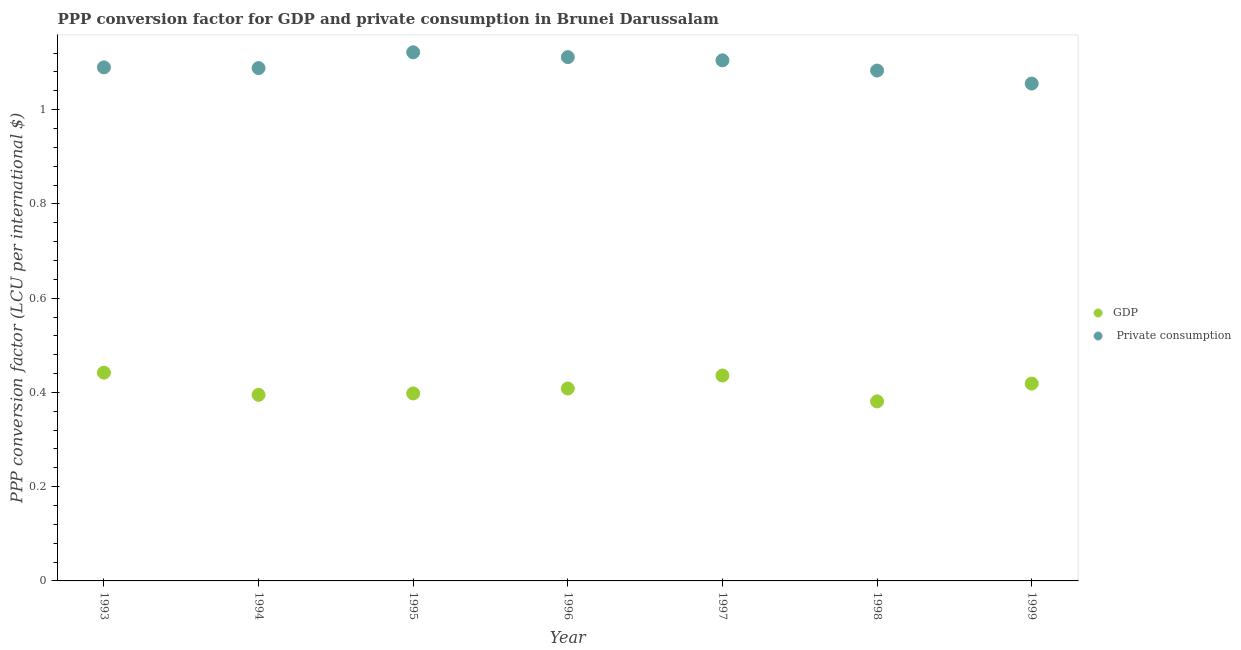How many different coloured dotlines are there?
Provide a short and direct response. 2. What is the ppp conversion factor for gdp in 1996?
Your answer should be compact. 0.41. Across all years, what is the maximum ppp conversion factor for private consumption?
Your answer should be compact. 1.12. Across all years, what is the minimum ppp conversion factor for private consumption?
Ensure brevity in your answer.  1.06. What is the total ppp conversion factor for gdp in the graph?
Provide a succinct answer. 2.88. What is the difference between the ppp conversion factor for gdp in 1993 and that in 1997?
Give a very brief answer. 0.01. What is the difference between the ppp conversion factor for gdp in 1994 and the ppp conversion factor for private consumption in 1993?
Your answer should be compact. -0.69. What is the average ppp conversion factor for gdp per year?
Your response must be concise. 0.41. In the year 1995, what is the difference between the ppp conversion factor for gdp and ppp conversion factor for private consumption?
Keep it short and to the point. -0.72. What is the ratio of the ppp conversion factor for gdp in 1995 to that in 1998?
Give a very brief answer. 1.04. Is the difference between the ppp conversion factor for private consumption in 1994 and 1999 greater than the difference between the ppp conversion factor for gdp in 1994 and 1999?
Ensure brevity in your answer.  Yes. What is the difference between the highest and the second highest ppp conversion factor for private consumption?
Keep it short and to the point. 0.01. What is the difference between the highest and the lowest ppp conversion factor for private consumption?
Give a very brief answer. 0.07. In how many years, is the ppp conversion factor for gdp greater than the average ppp conversion factor for gdp taken over all years?
Make the answer very short. 3. Is the ppp conversion factor for gdp strictly greater than the ppp conversion factor for private consumption over the years?
Offer a terse response. No. Is the ppp conversion factor for private consumption strictly less than the ppp conversion factor for gdp over the years?
Provide a short and direct response. No. How many dotlines are there?
Your response must be concise. 2. How many years are there in the graph?
Ensure brevity in your answer.  7. What is the difference between two consecutive major ticks on the Y-axis?
Provide a short and direct response. 0.2. Are the values on the major ticks of Y-axis written in scientific E-notation?
Make the answer very short. No. Does the graph contain any zero values?
Provide a succinct answer. No. How are the legend labels stacked?
Give a very brief answer. Vertical. What is the title of the graph?
Provide a succinct answer. PPP conversion factor for GDP and private consumption in Brunei Darussalam. What is the label or title of the X-axis?
Make the answer very short. Year. What is the label or title of the Y-axis?
Make the answer very short. PPP conversion factor (LCU per international $). What is the PPP conversion factor (LCU per international $) of GDP in 1993?
Offer a terse response. 0.44. What is the PPP conversion factor (LCU per international $) in  Private consumption in 1993?
Offer a very short reply. 1.09. What is the PPP conversion factor (LCU per international $) of GDP in 1994?
Give a very brief answer. 0.39. What is the PPP conversion factor (LCU per international $) of  Private consumption in 1994?
Your answer should be very brief. 1.09. What is the PPP conversion factor (LCU per international $) in GDP in 1995?
Provide a short and direct response. 0.4. What is the PPP conversion factor (LCU per international $) in  Private consumption in 1995?
Make the answer very short. 1.12. What is the PPP conversion factor (LCU per international $) of GDP in 1996?
Offer a very short reply. 0.41. What is the PPP conversion factor (LCU per international $) of  Private consumption in 1996?
Make the answer very short. 1.11. What is the PPP conversion factor (LCU per international $) in GDP in 1997?
Make the answer very short. 0.44. What is the PPP conversion factor (LCU per international $) of  Private consumption in 1997?
Make the answer very short. 1.1. What is the PPP conversion factor (LCU per international $) of GDP in 1998?
Your answer should be very brief. 0.38. What is the PPP conversion factor (LCU per international $) of  Private consumption in 1998?
Make the answer very short. 1.08. What is the PPP conversion factor (LCU per international $) of GDP in 1999?
Ensure brevity in your answer.  0.42. What is the PPP conversion factor (LCU per international $) in  Private consumption in 1999?
Provide a succinct answer. 1.06. Across all years, what is the maximum PPP conversion factor (LCU per international $) in GDP?
Provide a short and direct response. 0.44. Across all years, what is the maximum PPP conversion factor (LCU per international $) of  Private consumption?
Provide a succinct answer. 1.12. Across all years, what is the minimum PPP conversion factor (LCU per international $) of GDP?
Make the answer very short. 0.38. Across all years, what is the minimum PPP conversion factor (LCU per international $) in  Private consumption?
Offer a terse response. 1.06. What is the total PPP conversion factor (LCU per international $) of GDP in the graph?
Ensure brevity in your answer.  2.88. What is the total PPP conversion factor (LCU per international $) in  Private consumption in the graph?
Make the answer very short. 7.65. What is the difference between the PPP conversion factor (LCU per international $) in GDP in 1993 and that in 1994?
Give a very brief answer. 0.05. What is the difference between the PPP conversion factor (LCU per international $) in  Private consumption in 1993 and that in 1994?
Give a very brief answer. 0. What is the difference between the PPP conversion factor (LCU per international $) of GDP in 1993 and that in 1995?
Provide a succinct answer. 0.04. What is the difference between the PPP conversion factor (LCU per international $) of  Private consumption in 1993 and that in 1995?
Offer a very short reply. -0.03. What is the difference between the PPP conversion factor (LCU per international $) in GDP in 1993 and that in 1996?
Offer a very short reply. 0.03. What is the difference between the PPP conversion factor (LCU per international $) of  Private consumption in 1993 and that in 1996?
Keep it short and to the point. -0.02. What is the difference between the PPP conversion factor (LCU per international $) in GDP in 1993 and that in 1997?
Provide a succinct answer. 0.01. What is the difference between the PPP conversion factor (LCU per international $) of  Private consumption in 1993 and that in 1997?
Your answer should be compact. -0.01. What is the difference between the PPP conversion factor (LCU per international $) of GDP in 1993 and that in 1998?
Provide a succinct answer. 0.06. What is the difference between the PPP conversion factor (LCU per international $) in  Private consumption in 1993 and that in 1998?
Keep it short and to the point. 0.01. What is the difference between the PPP conversion factor (LCU per international $) of GDP in 1993 and that in 1999?
Your answer should be very brief. 0.02. What is the difference between the PPP conversion factor (LCU per international $) in  Private consumption in 1993 and that in 1999?
Make the answer very short. 0.03. What is the difference between the PPP conversion factor (LCU per international $) of GDP in 1994 and that in 1995?
Offer a terse response. -0. What is the difference between the PPP conversion factor (LCU per international $) of  Private consumption in 1994 and that in 1995?
Provide a short and direct response. -0.03. What is the difference between the PPP conversion factor (LCU per international $) in GDP in 1994 and that in 1996?
Your answer should be compact. -0.01. What is the difference between the PPP conversion factor (LCU per international $) in  Private consumption in 1994 and that in 1996?
Your response must be concise. -0.02. What is the difference between the PPP conversion factor (LCU per international $) in GDP in 1994 and that in 1997?
Your answer should be very brief. -0.04. What is the difference between the PPP conversion factor (LCU per international $) of  Private consumption in 1994 and that in 1997?
Provide a succinct answer. -0.02. What is the difference between the PPP conversion factor (LCU per international $) in GDP in 1994 and that in 1998?
Your answer should be very brief. 0.01. What is the difference between the PPP conversion factor (LCU per international $) in  Private consumption in 1994 and that in 1998?
Your answer should be compact. 0.01. What is the difference between the PPP conversion factor (LCU per international $) in GDP in 1994 and that in 1999?
Ensure brevity in your answer.  -0.02. What is the difference between the PPP conversion factor (LCU per international $) in  Private consumption in 1994 and that in 1999?
Your response must be concise. 0.03. What is the difference between the PPP conversion factor (LCU per international $) in GDP in 1995 and that in 1996?
Offer a terse response. -0.01. What is the difference between the PPP conversion factor (LCU per international $) in  Private consumption in 1995 and that in 1996?
Make the answer very short. 0.01. What is the difference between the PPP conversion factor (LCU per international $) in GDP in 1995 and that in 1997?
Your answer should be very brief. -0.04. What is the difference between the PPP conversion factor (LCU per international $) of  Private consumption in 1995 and that in 1997?
Offer a terse response. 0.02. What is the difference between the PPP conversion factor (LCU per international $) in GDP in 1995 and that in 1998?
Ensure brevity in your answer.  0.02. What is the difference between the PPP conversion factor (LCU per international $) in  Private consumption in 1995 and that in 1998?
Make the answer very short. 0.04. What is the difference between the PPP conversion factor (LCU per international $) in GDP in 1995 and that in 1999?
Your answer should be very brief. -0.02. What is the difference between the PPP conversion factor (LCU per international $) in  Private consumption in 1995 and that in 1999?
Your response must be concise. 0.07. What is the difference between the PPP conversion factor (LCU per international $) in GDP in 1996 and that in 1997?
Offer a terse response. -0.03. What is the difference between the PPP conversion factor (LCU per international $) in  Private consumption in 1996 and that in 1997?
Provide a short and direct response. 0.01. What is the difference between the PPP conversion factor (LCU per international $) of GDP in 1996 and that in 1998?
Provide a short and direct response. 0.03. What is the difference between the PPP conversion factor (LCU per international $) in  Private consumption in 1996 and that in 1998?
Your answer should be very brief. 0.03. What is the difference between the PPP conversion factor (LCU per international $) in GDP in 1996 and that in 1999?
Offer a very short reply. -0.01. What is the difference between the PPP conversion factor (LCU per international $) in  Private consumption in 1996 and that in 1999?
Your response must be concise. 0.06. What is the difference between the PPP conversion factor (LCU per international $) in GDP in 1997 and that in 1998?
Keep it short and to the point. 0.05. What is the difference between the PPP conversion factor (LCU per international $) in  Private consumption in 1997 and that in 1998?
Give a very brief answer. 0.02. What is the difference between the PPP conversion factor (LCU per international $) in GDP in 1997 and that in 1999?
Make the answer very short. 0.02. What is the difference between the PPP conversion factor (LCU per international $) of  Private consumption in 1997 and that in 1999?
Your response must be concise. 0.05. What is the difference between the PPP conversion factor (LCU per international $) in GDP in 1998 and that in 1999?
Your answer should be very brief. -0.04. What is the difference between the PPP conversion factor (LCU per international $) of  Private consumption in 1998 and that in 1999?
Give a very brief answer. 0.03. What is the difference between the PPP conversion factor (LCU per international $) in GDP in 1993 and the PPP conversion factor (LCU per international $) in  Private consumption in 1994?
Give a very brief answer. -0.65. What is the difference between the PPP conversion factor (LCU per international $) of GDP in 1993 and the PPP conversion factor (LCU per international $) of  Private consumption in 1995?
Your response must be concise. -0.68. What is the difference between the PPP conversion factor (LCU per international $) in GDP in 1993 and the PPP conversion factor (LCU per international $) in  Private consumption in 1996?
Your response must be concise. -0.67. What is the difference between the PPP conversion factor (LCU per international $) of GDP in 1993 and the PPP conversion factor (LCU per international $) of  Private consumption in 1997?
Keep it short and to the point. -0.66. What is the difference between the PPP conversion factor (LCU per international $) of GDP in 1993 and the PPP conversion factor (LCU per international $) of  Private consumption in 1998?
Offer a terse response. -0.64. What is the difference between the PPP conversion factor (LCU per international $) of GDP in 1993 and the PPP conversion factor (LCU per international $) of  Private consumption in 1999?
Ensure brevity in your answer.  -0.61. What is the difference between the PPP conversion factor (LCU per international $) in GDP in 1994 and the PPP conversion factor (LCU per international $) in  Private consumption in 1995?
Offer a very short reply. -0.73. What is the difference between the PPP conversion factor (LCU per international $) of GDP in 1994 and the PPP conversion factor (LCU per international $) of  Private consumption in 1996?
Provide a short and direct response. -0.72. What is the difference between the PPP conversion factor (LCU per international $) in GDP in 1994 and the PPP conversion factor (LCU per international $) in  Private consumption in 1997?
Provide a short and direct response. -0.71. What is the difference between the PPP conversion factor (LCU per international $) in GDP in 1994 and the PPP conversion factor (LCU per international $) in  Private consumption in 1998?
Give a very brief answer. -0.69. What is the difference between the PPP conversion factor (LCU per international $) in GDP in 1994 and the PPP conversion factor (LCU per international $) in  Private consumption in 1999?
Your answer should be compact. -0.66. What is the difference between the PPP conversion factor (LCU per international $) in GDP in 1995 and the PPP conversion factor (LCU per international $) in  Private consumption in 1996?
Keep it short and to the point. -0.71. What is the difference between the PPP conversion factor (LCU per international $) of GDP in 1995 and the PPP conversion factor (LCU per international $) of  Private consumption in 1997?
Your answer should be compact. -0.71. What is the difference between the PPP conversion factor (LCU per international $) in GDP in 1995 and the PPP conversion factor (LCU per international $) in  Private consumption in 1998?
Keep it short and to the point. -0.69. What is the difference between the PPP conversion factor (LCU per international $) of GDP in 1995 and the PPP conversion factor (LCU per international $) of  Private consumption in 1999?
Ensure brevity in your answer.  -0.66. What is the difference between the PPP conversion factor (LCU per international $) of GDP in 1996 and the PPP conversion factor (LCU per international $) of  Private consumption in 1997?
Offer a terse response. -0.7. What is the difference between the PPP conversion factor (LCU per international $) in GDP in 1996 and the PPP conversion factor (LCU per international $) in  Private consumption in 1998?
Offer a very short reply. -0.67. What is the difference between the PPP conversion factor (LCU per international $) in GDP in 1996 and the PPP conversion factor (LCU per international $) in  Private consumption in 1999?
Your answer should be very brief. -0.65. What is the difference between the PPP conversion factor (LCU per international $) in GDP in 1997 and the PPP conversion factor (LCU per international $) in  Private consumption in 1998?
Offer a very short reply. -0.65. What is the difference between the PPP conversion factor (LCU per international $) of GDP in 1997 and the PPP conversion factor (LCU per international $) of  Private consumption in 1999?
Ensure brevity in your answer.  -0.62. What is the difference between the PPP conversion factor (LCU per international $) in GDP in 1998 and the PPP conversion factor (LCU per international $) in  Private consumption in 1999?
Keep it short and to the point. -0.67. What is the average PPP conversion factor (LCU per international $) of GDP per year?
Ensure brevity in your answer.  0.41. What is the average PPP conversion factor (LCU per international $) in  Private consumption per year?
Your answer should be very brief. 1.09. In the year 1993, what is the difference between the PPP conversion factor (LCU per international $) in GDP and PPP conversion factor (LCU per international $) in  Private consumption?
Ensure brevity in your answer.  -0.65. In the year 1994, what is the difference between the PPP conversion factor (LCU per international $) in GDP and PPP conversion factor (LCU per international $) in  Private consumption?
Your answer should be compact. -0.69. In the year 1995, what is the difference between the PPP conversion factor (LCU per international $) of GDP and PPP conversion factor (LCU per international $) of  Private consumption?
Offer a terse response. -0.72. In the year 1996, what is the difference between the PPP conversion factor (LCU per international $) of GDP and PPP conversion factor (LCU per international $) of  Private consumption?
Provide a succinct answer. -0.7. In the year 1997, what is the difference between the PPP conversion factor (LCU per international $) in GDP and PPP conversion factor (LCU per international $) in  Private consumption?
Give a very brief answer. -0.67. In the year 1998, what is the difference between the PPP conversion factor (LCU per international $) in GDP and PPP conversion factor (LCU per international $) in  Private consumption?
Provide a succinct answer. -0.7. In the year 1999, what is the difference between the PPP conversion factor (LCU per international $) of GDP and PPP conversion factor (LCU per international $) of  Private consumption?
Make the answer very short. -0.64. What is the ratio of the PPP conversion factor (LCU per international $) in GDP in 1993 to that in 1994?
Your answer should be compact. 1.12. What is the ratio of the PPP conversion factor (LCU per international $) of GDP in 1993 to that in 1995?
Offer a terse response. 1.11. What is the ratio of the PPP conversion factor (LCU per international $) of  Private consumption in 1993 to that in 1995?
Your response must be concise. 0.97. What is the ratio of the PPP conversion factor (LCU per international $) in GDP in 1993 to that in 1996?
Ensure brevity in your answer.  1.08. What is the ratio of the PPP conversion factor (LCU per international $) of  Private consumption in 1993 to that in 1996?
Your answer should be very brief. 0.98. What is the ratio of the PPP conversion factor (LCU per international $) in  Private consumption in 1993 to that in 1997?
Your answer should be compact. 0.99. What is the ratio of the PPP conversion factor (LCU per international $) in GDP in 1993 to that in 1998?
Your answer should be very brief. 1.16. What is the ratio of the PPP conversion factor (LCU per international $) in  Private consumption in 1993 to that in 1998?
Offer a terse response. 1.01. What is the ratio of the PPP conversion factor (LCU per international $) in GDP in 1993 to that in 1999?
Provide a short and direct response. 1.06. What is the ratio of the PPP conversion factor (LCU per international $) in  Private consumption in 1993 to that in 1999?
Your response must be concise. 1.03. What is the ratio of the PPP conversion factor (LCU per international $) in GDP in 1994 to that in 1995?
Your answer should be compact. 0.99. What is the ratio of the PPP conversion factor (LCU per international $) in  Private consumption in 1994 to that in 1995?
Your answer should be very brief. 0.97. What is the ratio of the PPP conversion factor (LCU per international $) of GDP in 1994 to that in 1996?
Keep it short and to the point. 0.97. What is the ratio of the PPP conversion factor (LCU per international $) in  Private consumption in 1994 to that in 1996?
Give a very brief answer. 0.98. What is the ratio of the PPP conversion factor (LCU per international $) of GDP in 1994 to that in 1997?
Your answer should be very brief. 0.91. What is the ratio of the PPP conversion factor (LCU per international $) in  Private consumption in 1994 to that in 1997?
Offer a terse response. 0.99. What is the ratio of the PPP conversion factor (LCU per international $) of GDP in 1994 to that in 1998?
Provide a succinct answer. 1.04. What is the ratio of the PPP conversion factor (LCU per international $) of GDP in 1994 to that in 1999?
Make the answer very short. 0.94. What is the ratio of the PPP conversion factor (LCU per international $) of  Private consumption in 1994 to that in 1999?
Make the answer very short. 1.03. What is the ratio of the PPP conversion factor (LCU per international $) of GDP in 1995 to that in 1996?
Your response must be concise. 0.97. What is the ratio of the PPP conversion factor (LCU per international $) in  Private consumption in 1995 to that in 1996?
Offer a very short reply. 1.01. What is the ratio of the PPP conversion factor (LCU per international $) of GDP in 1995 to that in 1997?
Ensure brevity in your answer.  0.91. What is the ratio of the PPP conversion factor (LCU per international $) of  Private consumption in 1995 to that in 1997?
Make the answer very short. 1.02. What is the ratio of the PPP conversion factor (LCU per international $) of GDP in 1995 to that in 1998?
Provide a succinct answer. 1.04. What is the ratio of the PPP conversion factor (LCU per international $) of  Private consumption in 1995 to that in 1998?
Provide a succinct answer. 1.04. What is the ratio of the PPP conversion factor (LCU per international $) of GDP in 1995 to that in 1999?
Offer a very short reply. 0.95. What is the ratio of the PPP conversion factor (LCU per international $) in  Private consumption in 1995 to that in 1999?
Give a very brief answer. 1.06. What is the ratio of the PPP conversion factor (LCU per international $) in GDP in 1996 to that in 1997?
Provide a succinct answer. 0.94. What is the ratio of the PPP conversion factor (LCU per international $) of  Private consumption in 1996 to that in 1997?
Provide a succinct answer. 1.01. What is the ratio of the PPP conversion factor (LCU per international $) in GDP in 1996 to that in 1998?
Provide a short and direct response. 1.07. What is the ratio of the PPP conversion factor (LCU per international $) of  Private consumption in 1996 to that in 1998?
Give a very brief answer. 1.03. What is the ratio of the PPP conversion factor (LCU per international $) in GDP in 1996 to that in 1999?
Provide a short and direct response. 0.98. What is the ratio of the PPP conversion factor (LCU per international $) of  Private consumption in 1996 to that in 1999?
Give a very brief answer. 1.05. What is the ratio of the PPP conversion factor (LCU per international $) of GDP in 1997 to that in 1998?
Give a very brief answer. 1.14. What is the ratio of the PPP conversion factor (LCU per international $) in  Private consumption in 1997 to that in 1998?
Your response must be concise. 1.02. What is the ratio of the PPP conversion factor (LCU per international $) of GDP in 1997 to that in 1999?
Make the answer very short. 1.04. What is the ratio of the PPP conversion factor (LCU per international $) of  Private consumption in 1997 to that in 1999?
Your answer should be very brief. 1.05. What is the ratio of the PPP conversion factor (LCU per international $) of GDP in 1998 to that in 1999?
Your answer should be very brief. 0.91. What is the ratio of the PPP conversion factor (LCU per international $) in  Private consumption in 1998 to that in 1999?
Make the answer very short. 1.03. What is the difference between the highest and the second highest PPP conversion factor (LCU per international $) in GDP?
Your response must be concise. 0.01. What is the difference between the highest and the second highest PPP conversion factor (LCU per international $) of  Private consumption?
Your answer should be very brief. 0.01. What is the difference between the highest and the lowest PPP conversion factor (LCU per international $) of GDP?
Your answer should be compact. 0.06. What is the difference between the highest and the lowest PPP conversion factor (LCU per international $) in  Private consumption?
Provide a succinct answer. 0.07. 